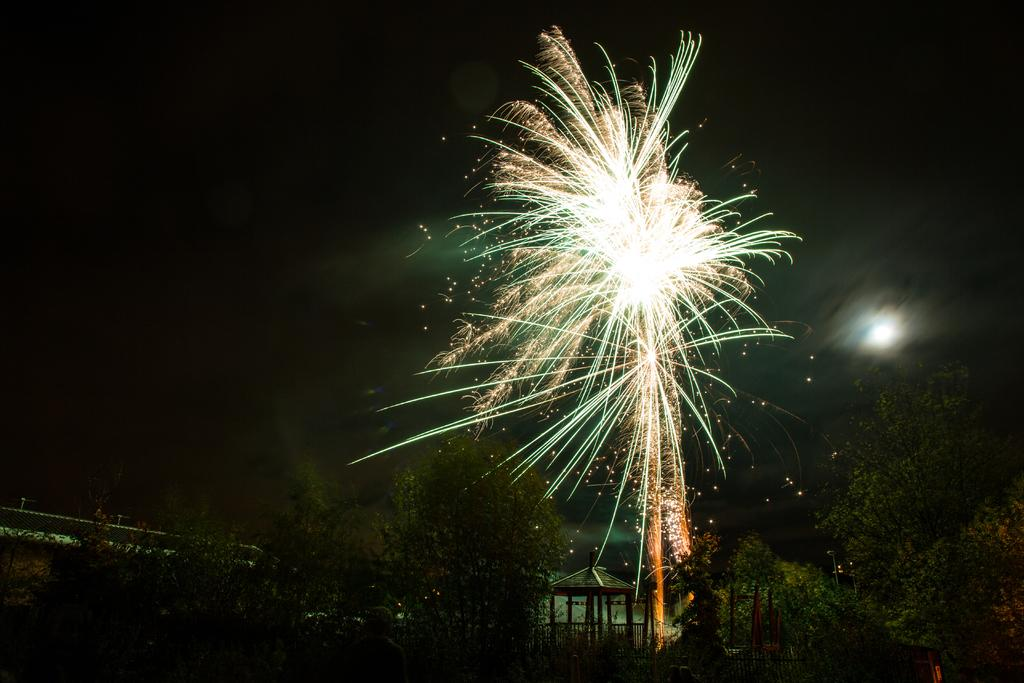What can be seen at the top of the image? The sky is visible in the image. What is present in the sky? There are sparkles in the sky. What type of vegetation is at the bottom of the image? There are trees at the bottom of the image. What structure is also present at the bottom of the image? There is a shed at the bottom of the image. What feature surrounds the shed? There is a railing around the shed. How would you describe the overall lighting in the image? The image is dark. Can you see the ant's partner in the bedroom in the image? There is no ant, partner, or bedroom present in the image. 